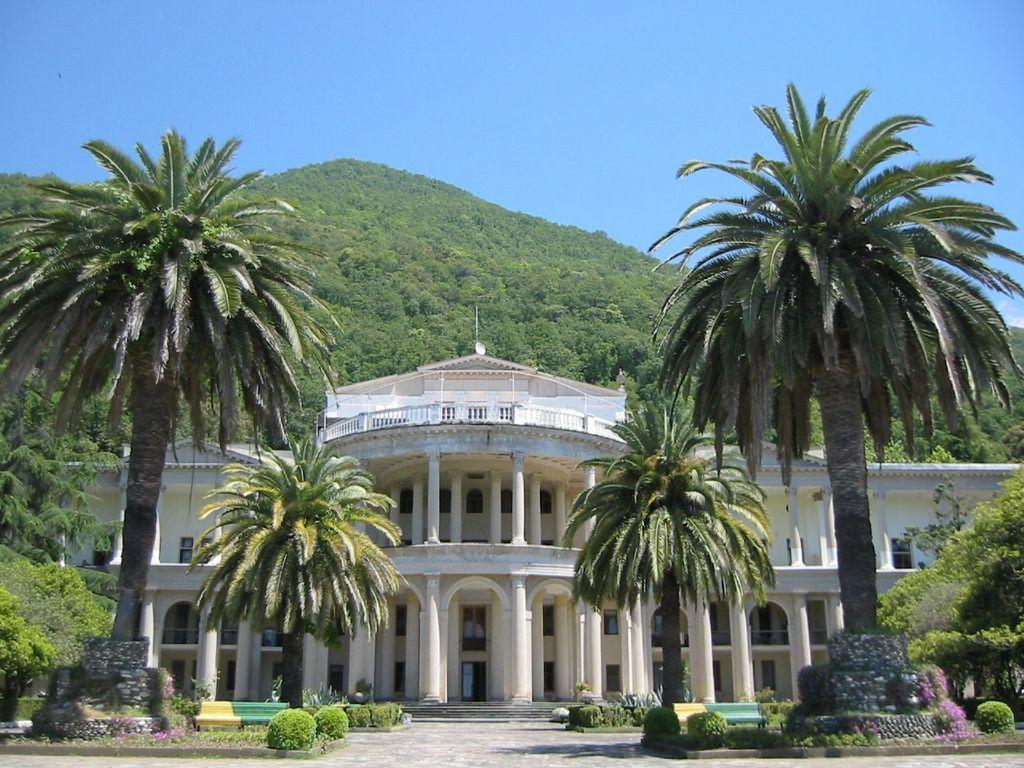What type of structure is visible in the image? There is a building in the image. What natural elements can be seen in the image? There are trees and a hill in the image. What is the color of the sky in the image? The sky is blue in the image. What type of vegetation is present in the image? There are plants in the image. Where is the power line located in the image? There is no power line present in the image. What type of rail can be seen in the image? There is no rail present in the image. 